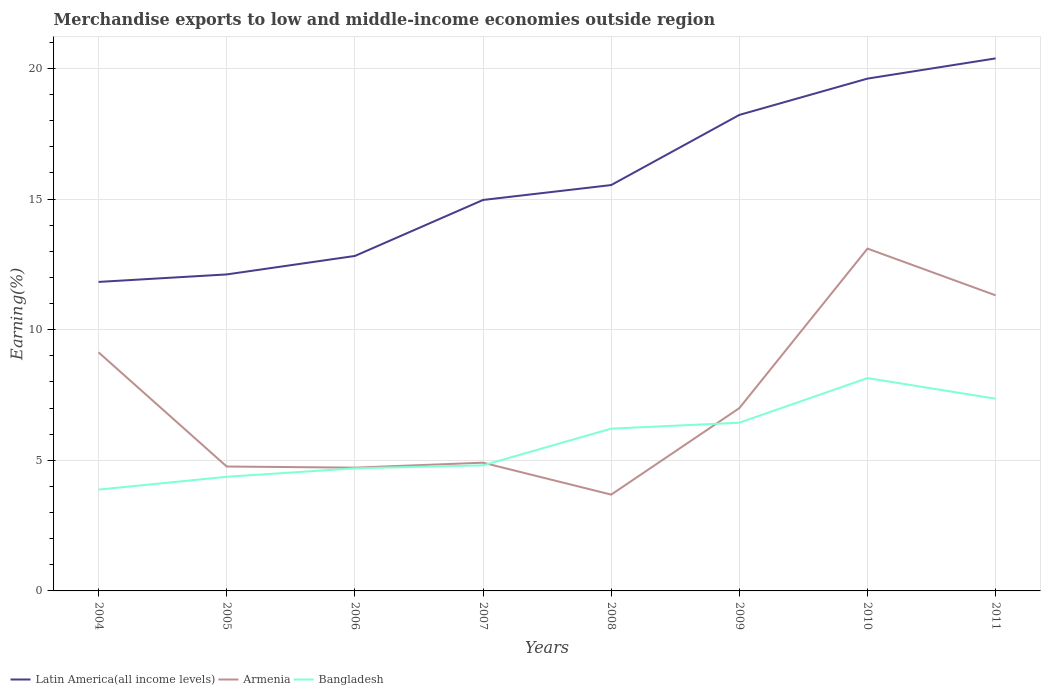Is the number of lines equal to the number of legend labels?
Your answer should be very brief. Yes. Across all years, what is the maximum percentage of amount earned from merchandise exports in Armenia?
Ensure brevity in your answer.  3.69. In which year was the percentage of amount earned from merchandise exports in Latin America(all income levels) maximum?
Ensure brevity in your answer.  2004. What is the total percentage of amount earned from merchandise exports in Latin America(all income levels) in the graph?
Offer a very short reply. -0.57. What is the difference between the highest and the second highest percentage of amount earned from merchandise exports in Bangladesh?
Make the answer very short. 4.27. Is the percentage of amount earned from merchandise exports in Latin America(all income levels) strictly greater than the percentage of amount earned from merchandise exports in Armenia over the years?
Ensure brevity in your answer.  No. How many years are there in the graph?
Offer a terse response. 8. How many legend labels are there?
Give a very brief answer. 3. How are the legend labels stacked?
Provide a short and direct response. Horizontal. What is the title of the graph?
Keep it short and to the point. Merchandise exports to low and middle-income economies outside region. What is the label or title of the Y-axis?
Ensure brevity in your answer.  Earning(%). What is the Earning(%) of Latin America(all income levels) in 2004?
Keep it short and to the point. 11.83. What is the Earning(%) of Armenia in 2004?
Offer a very short reply. 9.13. What is the Earning(%) in Bangladesh in 2004?
Provide a succinct answer. 3.88. What is the Earning(%) in Latin America(all income levels) in 2005?
Make the answer very short. 12.12. What is the Earning(%) in Armenia in 2005?
Make the answer very short. 4.76. What is the Earning(%) in Bangladesh in 2005?
Offer a very short reply. 4.37. What is the Earning(%) in Latin America(all income levels) in 2006?
Your response must be concise. 12.82. What is the Earning(%) in Armenia in 2006?
Keep it short and to the point. 4.72. What is the Earning(%) of Bangladesh in 2006?
Ensure brevity in your answer.  4.69. What is the Earning(%) in Latin America(all income levels) in 2007?
Keep it short and to the point. 14.97. What is the Earning(%) of Armenia in 2007?
Your response must be concise. 4.91. What is the Earning(%) in Bangladesh in 2007?
Offer a very short reply. 4.81. What is the Earning(%) of Latin America(all income levels) in 2008?
Give a very brief answer. 15.54. What is the Earning(%) of Armenia in 2008?
Your response must be concise. 3.69. What is the Earning(%) of Bangladesh in 2008?
Offer a terse response. 6.21. What is the Earning(%) in Latin America(all income levels) in 2009?
Offer a terse response. 18.22. What is the Earning(%) in Armenia in 2009?
Ensure brevity in your answer.  7. What is the Earning(%) of Bangladesh in 2009?
Give a very brief answer. 6.44. What is the Earning(%) of Latin America(all income levels) in 2010?
Offer a terse response. 19.61. What is the Earning(%) of Armenia in 2010?
Provide a short and direct response. 13.1. What is the Earning(%) in Bangladesh in 2010?
Ensure brevity in your answer.  8.15. What is the Earning(%) in Latin America(all income levels) in 2011?
Offer a terse response. 20.39. What is the Earning(%) of Armenia in 2011?
Keep it short and to the point. 11.32. What is the Earning(%) of Bangladesh in 2011?
Your answer should be compact. 7.36. Across all years, what is the maximum Earning(%) in Latin America(all income levels)?
Keep it short and to the point. 20.39. Across all years, what is the maximum Earning(%) of Armenia?
Make the answer very short. 13.1. Across all years, what is the maximum Earning(%) in Bangladesh?
Ensure brevity in your answer.  8.15. Across all years, what is the minimum Earning(%) in Latin America(all income levels)?
Offer a terse response. 11.83. Across all years, what is the minimum Earning(%) in Armenia?
Offer a very short reply. 3.69. Across all years, what is the minimum Earning(%) of Bangladesh?
Provide a succinct answer. 3.88. What is the total Earning(%) of Latin America(all income levels) in the graph?
Your response must be concise. 125.49. What is the total Earning(%) of Armenia in the graph?
Your response must be concise. 58.62. What is the total Earning(%) in Bangladesh in the graph?
Provide a succinct answer. 45.9. What is the difference between the Earning(%) in Latin America(all income levels) in 2004 and that in 2005?
Your answer should be very brief. -0.29. What is the difference between the Earning(%) in Armenia in 2004 and that in 2005?
Your answer should be compact. 4.37. What is the difference between the Earning(%) of Bangladesh in 2004 and that in 2005?
Your response must be concise. -0.49. What is the difference between the Earning(%) of Latin America(all income levels) in 2004 and that in 2006?
Make the answer very short. -0.99. What is the difference between the Earning(%) of Armenia in 2004 and that in 2006?
Provide a succinct answer. 4.41. What is the difference between the Earning(%) of Bangladesh in 2004 and that in 2006?
Your answer should be very brief. -0.81. What is the difference between the Earning(%) of Latin America(all income levels) in 2004 and that in 2007?
Your response must be concise. -3.14. What is the difference between the Earning(%) in Armenia in 2004 and that in 2007?
Your answer should be very brief. 4.22. What is the difference between the Earning(%) of Bangladesh in 2004 and that in 2007?
Keep it short and to the point. -0.93. What is the difference between the Earning(%) of Latin America(all income levels) in 2004 and that in 2008?
Your response must be concise. -3.71. What is the difference between the Earning(%) of Armenia in 2004 and that in 2008?
Your answer should be very brief. 5.45. What is the difference between the Earning(%) of Bangladesh in 2004 and that in 2008?
Your answer should be compact. -2.33. What is the difference between the Earning(%) in Latin America(all income levels) in 2004 and that in 2009?
Your response must be concise. -6.39. What is the difference between the Earning(%) in Armenia in 2004 and that in 2009?
Ensure brevity in your answer.  2.14. What is the difference between the Earning(%) in Bangladesh in 2004 and that in 2009?
Ensure brevity in your answer.  -2.56. What is the difference between the Earning(%) in Latin America(all income levels) in 2004 and that in 2010?
Offer a very short reply. -7.78. What is the difference between the Earning(%) in Armenia in 2004 and that in 2010?
Keep it short and to the point. -3.97. What is the difference between the Earning(%) of Bangladesh in 2004 and that in 2010?
Your answer should be very brief. -4.27. What is the difference between the Earning(%) in Latin America(all income levels) in 2004 and that in 2011?
Offer a very short reply. -8.56. What is the difference between the Earning(%) in Armenia in 2004 and that in 2011?
Offer a very short reply. -2.18. What is the difference between the Earning(%) in Bangladesh in 2004 and that in 2011?
Keep it short and to the point. -3.48. What is the difference between the Earning(%) in Latin America(all income levels) in 2005 and that in 2006?
Your response must be concise. -0.71. What is the difference between the Earning(%) of Armenia in 2005 and that in 2006?
Ensure brevity in your answer.  0.04. What is the difference between the Earning(%) in Bangladesh in 2005 and that in 2006?
Ensure brevity in your answer.  -0.32. What is the difference between the Earning(%) of Latin America(all income levels) in 2005 and that in 2007?
Ensure brevity in your answer.  -2.85. What is the difference between the Earning(%) in Armenia in 2005 and that in 2007?
Provide a succinct answer. -0.15. What is the difference between the Earning(%) in Bangladesh in 2005 and that in 2007?
Ensure brevity in your answer.  -0.44. What is the difference between the Earning(%) of Latin America(all income levels) in 2005 and that in 2008?
Your answer should be compact. -3.42. What is the difference between the Earning(%) of Armenia in 2005 and that in 2008?
Make the answer very short. 1.08. What is the difference between the Earning(%) of Bangladesh in 2005 and that in 2008?
Your answer should be compact. -1.84. What is the difference between the Earning(%) of Latin America(all income levels) in 2005 and that in 2009?
Provide a short and direct response. -6.11. What is the difference between the Earning(%) in Armenia in 2005 and that in 2009?
Ensure brevity in your answer.  -2.24. What is the difference between the Earning(%) in Bangladesh in 2005 and that in 2009?
Your response must be concise. -2.07. What is the difference between the Earning(%) of Latin America(all income levels) in 2005 and that in 2010?
Give a very brief answer. -7.5. What is the difference between the Earning(%) of Armenia in 2005 and that in 2010?
Provide a succinct answer. -8.34. What is the difference between the Earning(%) in Bangladesh in 2005 and that in 2010?
Your answer should be very brief. -3.78. What is the difference between the Earning(%) of Latin America(all income levels) in 2005 and that in 2011?
Provide a short and direct response. -8.27. What is the difference between the Earning(%) of Armenia in 2005 and that in 2011?
Give a very brief answer. -6.55. What is the difference between the Earning(%) in Bangladesh in 2005 and that in 2011?
Provide a succinct answer. -2.99. What is the difference between the Earning(%) of Latin America(all income levels) in 2006 and that in 2007?
Offer a terse response. -2.14. What is the difference between the Earning(%) of Armenia in 2006 and that in 2007?
Offer a very short reply. -0.19. What is the difference between the Earning(%) of Bangladesh in 2006 and that in 2007?
Ensure brevity in your answer.  -0.11. What is the difference between the Earning(%) of Latin America(all income levels) in 2006 and that in 2008?
Provide a succinct answer. -2.71. What is the difference between the Earning(%) in Armenia in 2006 and that in 2008?
Keep it short and to the point. 1.03. What is the difference between the Earning(%) of Bangladesh in 2006 and that in 2008?
Keep it short and to the point. -1.52. What is the difference between the Earning(%) of Latin America(all income levels) in 2006 and that in 2009?
Provide a short and direct response. -5.4. What is the difference between the Earning(%) of Armenia in 2006 and that in 2009?
Offer a terse response. -2.28. What is the difference between the Earning(%) of Bangladesh in 2006 and that in 2009?
Provide a succinct answer. -1.75. What is the difference between the Earning(%) of Latin America(all income levels) in 2006 and that in 2010?
Make the answer very short. -6.79. What is the difference between the Earning(%) of Armenia in 2006 and that in 2010?
Ensure brevity in your answer.  -8.38. What is the difference between the Earning(%) in Bangladesh in 2006 and that in 2010?
Provide a short and direct response. -3.45. What is the difference between the Earning(%) of Latin America(all income levels) in 2006 and that in 2011?
Offer a terse response. -7.56. What is the difference between the Earning(%) in Armenia in 2006 and that in 2011?
Give a very brief answer. -6.6. What is the difference between the Earning(%) of Bangladesh in 2006 and that in 2011?
Your answer should be very brief. -2.66. What is the difference between the Earning(%) of Latin America(all income levels) in 2007 and that in 2008?
Ensure brevity in your answer.  -0.57. What is the difference between the Earning(%) of Armenia in 2007 and that in 2008?
Keep it short and to the point. 1.22. What is the difference between the Earning(%) of Bangladesh in 2007 and that in 2008?
Offer a very short reply. -1.41. What is the difference between the Earning(%) of Latin America(all income levels) in 2007 and that in 2009?
Give a very brief answer. -3.26. What is the difference between the Earning(%) of Armenia in 2007 and that in 2009?
Keep it short and to the point. -2.09. What is the difference between the Earning(%) of Bangladesh in 2007 and that in 2009?
Your response must be concise. -1.63. What is the difference between the Earning(%) of Latin America(all income levels) in 2007 and that in 2010?
Offer a very short reply. -4.65. What is the difference between the Earning(%) of Armenia in 2007 and that in 2010?
Your answer should be very brief. -8.2. What is the difference between the Earning(%) in Bangladesh in 2007 and that in 2010?
Offer a terse response. -3.34. What is the difference between the Earning(%) of Latin America(all income levels) in 2007 and that in 2011?
Make the answer very short. -5.42. What is the difference between the Earning(%) in Armenia in 2007 and that in 2011?
Keep it short and to the point. -6.41. What is the difference between the Earning(%) of Bangladesh in 2007 and that in 2011?
Make the answer very short. -2.55. What is the difference between the Earning(%) of Latin America(all income levels) in 2008 and that in 2009?
Provide a succinct answer. -2.69. What is the difference between the Earning(%) in Armenia in 2008 and that in 2009?
Your answer should be very brief. -3.31. What is the difference between the Earning(%) in Bangladesh in 2008 and that in 2009?
Your answer should be very brief. -0.23. What is the difference between the Earning(%) in Latin America(all income levels) in 2008 and that in 2010?
Give a very brief answer. -4.08. What is the difference between the Earning(%) of Armenia in 2008 and that in 2010?
Make the answer very short. -9.42. What is the difference between the Earning(%) of Bangladesh in 2008 and that in 2010?
Give a very brief answer. -1.94. What is the difference between the Earning(%) in Latin America(all income levels) in 2008 and that in 2011?
Your answer should be compact. -4.85. What is the difference between the Earning(%) of Armenia in 2008 and that in 2011?
Ensure brevity in your answer.  -7.63. What is the difference between the Earning(%) of Bangladesh in 2008 and that in 2011?
Make the answer very short. -1.15. What is the difference between the Earning(%) of Latin America(all income levels) in 2009 and that in 2010?
Provide a succinct answer. -1.39. What is the difference between the Earning(%) in Armenia in 2009 and that in 2010?
Offer a terse response. -6.11. What is the difference between the Earning(%) in Bangladesh in 2009 and that in 2010?
Provide a succinct answer. -1.71. What is the difference between the Earning(%) of Latin America(all income levels) in 2009 and that in 2011?
Provide a short and direct response. -2.16. What is the difference between the Earning(%) in Armenia in 2009 and that in 2011?
Your answer should be compact. -4.32. What is the difference between the Earning(%) of Bangladesh in 2009 and that in 2011?
Offer a very short reply. -0.92. What is the difference between the Earning(%) in Latin America(all income levels) in 2010 and that in 2011?
Ensure brevity in your answer.  -0.77. What is the difference between the Earning(%) in Armenia in 2010 and that in 2011?
Offer a terse response. 1.79. What is the difference between the Earning(%) of Bangladesh in 2010 and that in 2011?
Ensure brevity in your answer.  0.79. What is the difference between the Earning(%) in Latin America(all income levels) in 2004 and the Earning(%) in Armenia in 2005?
Provide a succinct answer. 7.07. What is the difference between the Earning(%) of Latin America(all income levels) in 2004 and the Earning(%) of Bangladesh in 2005?
Provide a short and direct response. 7.46. What is the difference between the Earning(%) of Armenia in 2004 and the Earning(%) of Bangladesh in 2005?
Your answer should be very brief. 4.76. What is the difference between the Earning(%) of Latin America(all income levels) in 2004 and the Earning(%) of Armenia in 2006?
Ensure brevity in your answer.  7.11. What is the difference between the Earning(%) in Latin America(all income levels) in 2004 and the Earning(%) in Bangladesh in 2006?
Give a very brief answer. 7.13. What is the difference between the Earning(%) of Armenia in 2004 and the Earning(%) of Bangladesh in 2006?
Offer a terse response. 4.44. What is the difference between the Earning(%) of Latin America(all income levels) in 2004 and the Earning(%) of Armenia in 2007?
Your answer should be very brief. 6.92. What is the difference between the Earning(%) in Latin America(all income levels) in 2004 and the Earning(%) in Bangladesh in 2007?
Make the answer very short. 7.02. What is the difference between the Earning(%) of Armenia in 2004 and the Earning(%) of Bangladesh in 2007?
Offer a very short reply. 4.33. What is the difference between the Earning(%) of Latin America(all income levels) in 2004 and the Earning(%) of Armenia in 2008?
Offer a very short reply. 8.14. What is the difference between the Earning(%) in Latin America(all income levels) in 2004 and the Earning(%) in Bangladesh in 2008?
Keep it short and to the point. 5.62. What is the difference between the Earning(%) in Armenia in 2004 and the Earning(%) in Bangladesh in 2008?
Give a very brief answer. 2.92. What is the difference between the Earning(%) of Latin America(all income levels) in 2004 and the Earning(%) of Armenia in 2009?
Provide a succinct answer. 4.83. What is the difference between the Earning(%) in Latin America(all income levels) in 2004 and the Earning(%) in Bangladesh in 2009?
Offer a terse response. 5.39. What is the difference between the Earning(%) in Armenia in 2004 and the Earning(%) in Bangladesh in 2009?
Ensure brevity in your answer.  2.69. What is the difference between the Earning(%) in Latin America(all income levels) in 2004 and the Earning(%) in Armenia in 2010?
Your answer should be very brief. -1.28. What is the difference between the Earning(%) in Latin America(all income levels) in 2004 and the Earning(%) in Bangladesh in 2010?
Offer a terse response. 3.68. What is the difference between the Earning(%) of Armenia in 2004 and the Earning(%) of Bangladesh in 2010?
Provide a succinct answer. 0.98. What is the difference between the Earning(%) in Latin America(all income levels) in 2004 and the Earning(%) in Armenia in 2011?
Make the answer very short. 0.51. What is the difference between the Earning(%) of Latin America(all income levels) in 2004 and the Earning(%) of Bangladesh in 2011?
Provide a short and direct response. 4.47. What is the difference between the Earning(%) in Armenia in 2004 and the Earning(%) in Bangladesh in 2011?
Your answer should be compact. 1.78. What is the difference between the Earning(%) in Latin America(all income levels) in 2005 and the Earning(%) in Armenia in 2006?
Make the answer very short. 7.4. What is the difference between the Earning(%) of Latin America(all income levels) in 2005 and the Earning(%) of Bangladesh in 2006?
Provide a short and direct response. 7.42. What is the difference between the Earning(%) of Armenia in 2005 and the Earning(%) of Bangladesh in 2006?
Your answer should be very brief. 0.07. What is the difference between the Earning(%) of Latin America(all income levels) in 2005 and the Earning(%) of Armenia in 2007?
Offer a terse response. 7.21. What is the difference between the Earning(%) in Latin America(all income levels) in 2005 and the Earning(%) in Bangladesh in 2007?
Provide a succinct answer. 7.31. What is the difference between the Earning(%) of Armenia in 2005 and the Earning(%) of Bangladesh in 2007?
Your answer should be very brief. -0.05. What is the difference between the Earning(%) of Latin America(all income levels) in 2005 and the Earning(%) of Armenia in 2008?
Your response must be concise. 8.43. What is the difference between the Earning(%) of Latin America(all income levels) in 2005 and the Earning(%) of Bangladesh in 2008?
Keep it short and to the point. 5.9. What is the difference between the Earning(%) in Armenia in 2005 and the Earning(%) in Bangladesh in 2008?
Your answer should be very brief. -1.45. What is the difference between the Earning(%) in Latin America(all income levels) in 2005 and the Earning(%) in Armenia in 2009?
Your response must be concise. 5.12. What is the difference between the Earning(%) in Latin America(all income levels) in 2005 and the Earning(%) in Bangladesh in 2009?
Your response must be concise. 5.68. What is the difference between the Earning(%) in Armenia in 2005 and the Earning(%) in Bangladesh in 2009?
Give a very brief answer. -1.68. What is the difference between the Earning(%) of Latin America(all income levels) in 2005 and the Earning(%) of Armenia in 2010?
Keep it short and to the point. -0.99. What is the difference between the Earning(%) in Latin America(all income levels) in 2005 and the Earning(%) in Bangladesh in 2010?
Provide a succinct answer. 3.97. What is the difference between the Earning(%) of Armenia in 2005 and the Earning(%) of Bangladesh in 2010?
Your answer should be very brief. -3.39. What is the difference between the Earning(%) of Latin America(all income levels) in 2005 and the Earning(%) of Armenia in 2011?
Make the answer very short. 0.8. What is the difference between the Earning(%) of Latin America(all income levels) in 2005 and the Earning(%) of Bangladesh in 2011?
Provide a short and direct response. 4.76. What is the difference between the Earning(%) in Armenia in 2005 and the Earning(%) in Bangladesh in 2011?
Make the answer very short. -2.6. What is the difference between the Earning(%) in Latin America(all income levels) in 2006 and the Earning(%) in Armenia in 2007?
Provide a succinct answer. 7.91. What is the difference between the Earning(%) in Latin America(all income levels) in 2006 and the Earning(%) in Bangladesh in 2007?
Give a very brief answer. 8.02. What is the difference between the Earning(%) of Armenia in 2006 and the Earning(%) of Bangladesh in 2007?
Offer a very short reply. -0.09. What is the difference between the Earning(%) in Latin America(all income levels) in 2006 and the Earning(%) in Armenia in 2008?
Provide a short and direct response. 9.14. What is the difference between the Earning(%) in Latin America(all income levels) in 2006 and the Earning(%) in Bangladesh in 2008?
Provide a short and direct response. 6.61. What is the difference between the Earning(%) of Armenia in 2006 and the Earning(%) of Bangladesh in 2008?
Offer a terse response. -1.49. What is the difference between the Earning(%) in Latin America(all income levels) in 2006 and the Earning(%) in Armenia in 2009?
Provide a short and direct response. 5.83. What is the difference between the Earning(%) of Latin America(all income levels) in 2006 and the Earning(%) of Bangladesh in 2009?
Give a very brief answer. 6.38. What is the difference between the Earning(%) of Armenia in 2006 and the Earning(%) of Bangladesh in 2009?
Offer a terse response. -1.72. What is the difference between the Earning(%) of Latin America(all income levels) in 2006 and the Earning(%) of Armenia in 2010?
Make the answer very short. -0.28. What is the difference between the Earning(%) of Latin America(all income levels) in 2006 and the Earning(%) of Bangladesh in 2010?
Your answer should be compact. 4.67. What is the difference between the Earning(%) in Armenia in 2006 and the Earning(%) in Bangladesh in 2010?
Provide a succinct answer. -3.43. What is the difference between the Earning(%) of Latin America(all income levels) in 2006 and the Earning(%) of Armenia in 2011?
Keep it short and to the point. 1.51. What is the difference between the Earning(%) of Latin America(all income levels) in 2006 and the Earning(%) of Bangladesh in 2011?
Provide a short and direct response. 5.47. What is the difference between the Earning(%) of Armenia in 2006 and the Earning(%) of Bangladesh in 2011?
Your answer should be compact. -2.64. What is the difference between the Earning(%) of Latin America(all income levels) in 2007 and the Earning(%) of Armenia in 2008?
Ensure brevity in your answer.  11.28. What is the difference between the Earning(%) of Latin America(all income levels) in 2007 and the Earning(%) of Bangladesh in 2008?
Provide a succinct answer. 8.75. What is the difference between the Earning(%) in Armenia in 2007 and the Earning(%) in Bangladesh in 2008?
Keep it short and to the point. -1.3. What is the difference between the Earning(%) of Latin America(all income levels) in 2007 and the Earning(%) of Armenia in 2009?
Your answer should be compact. 7.97. What is the difference between the Earning(%) of Latin America(all income levels) in 2007 and the Earning(%) of Bangladesh in 2009?
Your response must be concise. 8.53. What is the difference between the Earning(%) of Armenia in 2007 and the Earning(%) of Bangladesh in 2009?
Provide a succinct answer. -1.53. What is the difference between the Earning(%) of Latin America(all income levels) in 2007 and the Earning(%) of Armenia in 2010?
Offer a very short reply. 1.86. What is the difference between the Earning(%) in Latin America(all income levels) in 2007 and the Earning(%) in Bangladesh in 2010?
Offer a very short reply. 6.82. What is the difference between the Earning(%) of Armenia in 2007 and the Earning(%) of Bangladesh in 2010?
Offer a terse response. -3.24. What is the difference between the Earning(%) of Latin America(all income levels) in 2007 and the Earning(%) of Armenia in 2011?
Give a very brief answer. 3.65. What is the difference between the Earning(%) of Latin America(all income levels) in 2007 and the Earning(%) of Bangladesh in 2011?
Your response must be concise. 7.61. What is the difference between the Earning(%) in Armenia in 2007 and the Earning(%) in Bangladesh in 2011?
Give a very brief answer. -2.45. What is the difference between the Earning(%) of Latin America(all income levels) in 2008 and the Earning(%) of Armenia in 2009?
Ensure brevity in your answer.  8.54. What is the difference between the Earning(%) of Latin America(all income levels) in 2008 and the Earning(%) of Bangladesh in 2009?
Your answer should be very brief. 9.1. What is the difference between the Earning(%) of Armenia in 2008 and the Earning(%) of Bangladesh in 2009?
Provide a succinct answer. -2.75. What is the difference between the Earning(%) of Latin America(all income levels) in 2008 and the Earning(%) of Armenia in 2010?
Your answer should be compact. 2.43. What is the difference between the Earning(%) of Latin America(all income levels) in 2008 and the Earning(%) of Bangladesh in 2010?
Offer a terse response. 7.39. What is the difference between the Earning(%) of Armenia in 2008 and the Earning(%) of Bangladesh in 2010?
Make the answer very short. -4.46. What is the difference between the Earning(%) in Latin America(all income levels) in 2008 and the Earning(%) in Armenia in 2011?
Provide a short and direct response. 4.22. What is the difference between the Earning(%) in Latin America(all income levels) in 2008 and the Earning(%) in Bangladesh in 2011?
Your answer should be compact. 8.18. What is the difference between the Earning(%) in Armenia in 2008 and the Earning(%) in Bangladesh in 2011?
Keep it short and to the point. -3.67. What is the difference between the Earning(%) of Latin America(all income levels) in 2009 and the Earning(%) of Armenia in 2010?
Offer a very short reply. 5.12. What is the difference between the Earning(%) of Latin America(all income levels) in 2009 and the Earning(%) of Bangladesh in 2010?
Your response must be concise. 10.07. What is the difference between the Earning(%) of Armenia in 2009 and the Earning(%) of Bangladesh in 2010?
Offer a terse response. -1.15. What is the difference between the Earning(%) in Latin America(all income levels) in 2009 and the Earning(%) in Armenia in 2011?
Give a very brief answer. 6.91. What is the difference between the Earning(%) in Latin America(all income levels) in 2009 and the Earning(%) in Bangladesh in 2011?
Offer a terse response. 10.86. What is the difference between the Earning(%) in Armenia in 2009 and the Earning(%) in Bangladesh in 2011?
Keep it short and to the point. -0.36. What is the difference between the Earning(%) in Latin America(all income levels) in 2010 and the Earning(%) in Armenia in 2011?
Your answer should be very brief. 8.3. What is the difference between the Earning(%) in Latin America(all income levels) in 2010 and the Earning(%) in Bangladesh in 2011?
Offer a terse response. 12.25. What is the difference between the Earning(%) of Armenia in 2010 and the Earning(%) of Bangladesh in 2011?
Give a very brief answer. 5.75. What is the average Earning(%) in Latin America(all income levels) per year?
Make the answer very short. 15.69. What is the average Earning(%) in Armenia per year?
Give a very brief answer. 7.33. What is the average Earning(%) of Bangladesh per year?
Give a very brief answer. 5.74. In the year 2004, what is the difference between the Earning(%) of Latin America(all income levels) and Earning(%) of Armenia?
Make the answer very short. 2.7. In the year 2004, what is the difference between the Earning(%) in Latin America(all income levels) and Earning(%) in Bangladesh?
Your answer should be compact. 7.95. In the year 2004, what is the difference between the Earning(%) of Armenia and Earning(%) of Bangladesh?
Provide a short and direct response. 5.25. In the year 2005, what is the difference between the Earning(%) of Latin America(all income levels) and Earning(%) of Armenia?
Provide a short and direct response. 7.35. In the year 2005, what is the difference between the Earning(%) of Latin America(all income levels) and Earning(%) of Bangladesh?
Your answer should be very brief. 7.75. In the year 2005, what is the difference between the Earning(%) of Armenia and Earning(%) of Bangladesh?
Offer a very short reply. 0.39. In the year 2006, what is the difference between the Earning(%) of Latin America(all income levels) and Earning(%) of Armenia?
Make the answer very short. 8.1. In the year 2006, what is the difference between the Earning(%) of Latin America(all income levels) and Earning(%) of Bangladesh?
Make the answer very short. 8.13. In the year 2006, what is the difference between the Earning(%) of Armenia and Earning(%) of Bangladesh?
Your response must be concise. 0.03. In the year 2007, what is the difference between the Earning(%) of Latin America(all income levels) and Earning(%) of Armenia?
Provide a succinct answer. 10.06. In the year 2007, what is the difference between the Earning(%) in Latin America(all income levels) and Earning(%) in Bangladesh?
Your answer should be very brief. 10.16. In the year 2007, what is the difference between the Earning(%) of Armenia and Earning(%) of Bangladesh?
Make the answer very short. 0.1. In the year 2008, what is the difference between the Earning(%) in Latin America(all income levels) and Earning(%) in Armenia?
Offer a terse response. 11.85. In the year 2008, what is the difference between the Earning(%) of Latin America(all income levels) and Earning(%) of Bangladesh?
Provide a short and direct response. 9.32. In the year 2008, what is the difference between the Earning(%) in Armenia and Earning(%) in Bangladesh?
Offer a very short reply. -2.53. In the year 2009, what is the difference between the Earning(%) of Latin America(all income levels) and Earning(%) of Armenia?
Make the answer very short. 11.22. In the year 2009, what is the difference between the Earning(%) in Latin America(all income levels) and Earning(%) in Bangladesh?
Your answer should be very brief. 11.78. In the year 2009, what is the difference between the Earning(%) in Armenia and Earning(%) in Bangladesh?
Give a very brief answer. 0.56. In the year 2010, what is the difference between the Earning(%) of Latin America(all income levels) and Earning(%) of Armenia?
Provide a succinct answer. 6.51. In the year 2010, what is the difference between the Earning(%) of Latin America(all income levels) and Earning(%) of Bangladesh?
Give a very brief answer. 11.46. In the year 2010, what is the difference between the Earning(%) in Armenia and Earning(%) in Bangladesh?
Make the answer very short. 4.96. In the year 2011, what is the difference between the Earning(%) in Latin America(all income levels) and Earning(%) in Armenia?
Give a very brief answer. 9.07. In the year 2011, what is the difference between the Earning(%) of Latin America(all income levels) and Earning(%) of Bangladesh?
Your answer should be very brief. 13.03. In the year 2011, what is the difference between the Earning(%) of Armenia and Earning(%) of Bangladesh?
Provide a succinct answer. 3.96. What is the ratio of the Earning(%) of Latin America(all income levels) in 2004 to that in 2005?
Your answer should be compact. 0.98. What is the ratio of the Earning(%) of Armenia in 2004 to that in 2005?
Make the answer very short. 1.92. What is the ratio of the Earning(%) in Bangladesh in 2004 to that in 2005?
Give a very brief answer. 0.89. What is the ratio of the Earning(%) of Latin America(all income levels) in 2004 to that in 2006?
Provide a short and direct response. 0.92. What is the ratio of the Earning(%) in Armenia in 2004 to that in 2006?
Ensure brevity in your answer.  1.94. What is the ratio of the Earning(%) of Bangladesh in 2004 to that in 2006?
Provide a short and direct response. 0.83. What is the ratio of the Earning(%) in Latin America(all income levels) in 2004 to that in 2007?
Offer a terse response. 0.79. What is the ratio of the Earning(%) in Armenia in 2004 to that in 2007?
Ensure brevity in your answer.  1.86. What is the ratio of the Earning(%) in Bangladesh in 2004 to that in 2007?
Provide a short and direct response. 0.81. What is the ratio of the Earning(%) in Latin America(all income levels) in 2004 to that in 2008?
Provide a short and direct response. 0.76. What is the ratio of the Earning(%) in Armenia in 2004 to that in 2008?
Make the answer very short. 2.48. What is the ratio of the Earning(%) of Bangladesh in 2004 to that in 2008?
Give a very brief answer. 0.62. What is the ratio of the Earning(%) in Latin America(all income levels) in 2004 to that in 2009?
Keep it short and to the point. 0.65. What is the ratio of the Earning(%) in Armenia in 2004 to that in 2009?
Provide a succinct answer. 1.31. What is the ratio of the Earning(%) in Bangladesh in 2004 to that in 2009?
Offer a terse response. 0.6. What is the ratio of the Earning(%) in Latin America(all income levels) in 2004 to that in 2010?
Make the answer very short. 0.6. What is the ratio of the Earning(%) in Armenia in 2004 to that in 2010?
Make the answer very short. 0.7. What is the ratio of the Earning(%) of Bangladesh in 2004 to that in 2010?
Provide a succinct answer. 0.48. What is the ratio of the Earning(%) in Latin America(all income levels) in 2004 to that in 2011?
Offer a very short reply. 0.58. What is the ratio of the Earning(%) in Armenia in 2004 to that in 2011?
Offer a very short reply. 0.81. What is the ratio of the Earning(%) in Bangladesh in 2004 to that in 2011?
Give a very brief answer. 0.53. What is the ratio of the Earning(%) in Latin America(all income levels) in 2005 to that in 2006?
Your answer should be compact. 0.94. What is the ratio of the Earning(%) of Armenia in 2005 to that in 2006?
Your answer should be compact. 1.01. What is the ratio of the Earning(%) in Latin America(all income levels) in 2005 to that in 2007?
Your response must be concise. 0.81. What is the ratio of the Earning(%) of Armenia in 2005 to that in 2007?
Make the answer very short. 0.97. What is the ratio of the Earning(%) of Bangladesh in 2005 to that in 2007?
Keep it short and to the point. 0.91. What is the ratio of the Earning(%) in Latin America(all income levels) in 2005 to that in 2008?
Ensure brevity in your answer.  0.78. What is the ratio of the Earning(%) in Armenia in 2005 to that in 2008?
Keep it short and to the point. 1.29. What is the ratio of the Earning(%) in Bangladesh in 2005 to that in 2008?
Ensure brevity in your answer.  0.7. What is the ratio of the Earning(%) of Latin America(all income levels) in 2005 to that in 2009?
Offer a terse response. 0.66. What is the ratio of the Earning(%) in Armenia in 2005 to that in 2009?
Provide a short and direct response. 0.68. What is the ratio of the Earning(%) of Bangladesh in 2005 to that in 2009?
Provide a succinct answer. 0.68. What is the ratio of the Earning(%) of Latin America(all income levels) in 2005 to that in 2010?
Your answer should be compact. 0.62. What is the ratio of the Earning(%) in Armenia in 2005 to that in 2010?
Provide a succinct answer. 0.36. What is the ratio of the Earning(%) in Bangladesh in 2005 to that in 2010?
Provide a short and direct response. 0.54. What is the ratio of the Earning(%) of Latin America(all income levels) in 2005 to that in 2011?
Ensure brevity in your answer.  0.59. What is the ratio of the Earning(%) in Armenia in 2005 to that in 2011?
Your answer should be compact. 0.42. What is the ratio of the Earning(%) in Bangladesh in 2005 to that in 2011?
Keep it short and to the point. 0.59. What is the ratio of the Earning(%) of Latin America(all income levels) in 2006 to that in 2007?
Offer a terse response. 0.86. What is the ratio of the Earning(%) of Armenia in 2006 to that in 2007?
Your answer should be very brief. 0.96. What is the ratio of the Earning(%) of Bangladesh in 2006 to that in 2007?
Your answer should be very brief. 0.98. What is the ratio of the Earning(%) in Latin America(all income levels) in 2006 to that in 2008?
Keep it short and to the point. 0.83. What is the ratio of the Earning(%) in Armenia in 2006 to that in 2008?
Ensure brevity in your answer.  1.28. What is the ratio of the Earning(%) of Bangladesh in 2006 to that in 2008?
Your answer should be compact. 0.76. What is the ratio of the Earning(%) of Latin America(all income levels) in 2006 to that in 2009?
Offer a terse response. 0.7. What is the ratio of the Earning(%) of Armenia in 2006 to that in 2009?
Provide a succinct answer. 0.67. What is the ratio of the Earning(%) in Bangladesh in 2006 to that in 2009?
Provide a short and direct response. 0.73. What is the ratio of the Earning(%) in Latin America(all income levels) in 2006 to that in 2010?
Offer a very short reply. 0.65. What is the ratio of the Earning(%) in Armenia in 2006 to that in 2010?
Your answer should be compact. 0.36. What is the ratio of the Earning(%) in Bangladesh in 2006 to that in 2010?
Keep it short and to the point. 0.58. What is the ratio of the Earning(%) of Latin America(all income levels) in 2006 to that in 2011?
Offer a terse response. 0.63. What is the ratio of the Earning(%) in Armenia in 2006 to that in 2011?
Keep it short and to the point. 0.42. What is the ratio of the Earning(%) of Bangladesh in 2006 to that in 2011?
Make the answer very short. 0.64. What is the ratio of the Earning(%) of Latin America(all income levels) in 2007 to that in 2008?
Your answer should be very brief. 0.96. What is the ratio of the Earning(%) in Armenia in 2007 to that in 2008?
Offer a very short reply. 1.33. What is the ratio of the Earning(%) in Bangladesh in 2007 to that in 2008?
Provide a short and direct response. 0.77. What is the ratio of the Earning(%) of Latin America(all income levels) in 2007 to that in 2009?
Offer a very short reply. 0.82. What is the ratio of the Earning(%) of Armenia in 2007 to that in 2009?
Give a very brief answer. 0.7. What is the ratio of the Earning(%) of Bangladesh in 2007 to that in 2009?
Provide a succinct answer. 0.75. What is the ratio of the Earning(%) of Latin America(all income levels) in 2007 to that in 2010?
Make the answer very short. 0.76. What is the ratio of the Earning(%) of Armenia in 2007 to that in 2010?
Your answer should be very brief. 0.37. What is the ratio of the Earning(%) in Bangladesh in 2007 to that in 2010?
Make the answer very short. 0.59. What is the ratio of the Earning(%) of Latin America(all income levels) in 2007 to that in 2011?
Your answer should be very brief. 0.73. What is the ratio of the Earning(%) of Armenia in 2007 to that in 2011?
Provide a succinct answer. 0.43. What is the ratio of the Earning(%) of Bangladesh in 2007 to that in 2011?
Provide a short and direct response. 0.65. What is the ratio of the Earning(%) in Latin America(all income levels) in 2008 to that in 2009?
Your answer should be compact. 0.85. What is the ratio of the Earning(%) in Armenia in 2008 to that in 2009?
Give a very brief answer. 0.53. What is the ratio of the Earning(%) in Bangladesh in 2008 to that in 2009?
Your response must be concise. 0.96. What is the ratio of the Earning(%) of Latin America(all income levels) in 2008 to that in 2010?
Provide a succinct answer. 0.79. What is the ratio of the Earning(%) in Armenia in 2008 to that in 2010?
Ensure brevity in your answer.  0.28. What is the ratio of the Earning(%) in Bangladesh in 2008 to that in 2010?
Your response must be concise. 0.76. What is the ratio of the Earning(%) of Latin America(all income levels) in 2008 to that in 2011?
Give a very brief answer. 0.76. What is the ratio of the Earning(%) of Armenia in 2008 to that in 2011?
Ensure brevity in your answer.  0.33. What is the ratio of the Earning(%) in Bangladesh in 2008 to that in 2011?
Your answer should be very brief. 0.84. What is the ratio of the Earning(%) in Latin America(all income levels) in 2009 to that in 2010?
Your answer should be very brief. 0.93. What is the ratio of the Earning(%) in Armenia in 2009 to that in 2010?
Provide a succinct answer. 0.53. What is the ratio of the Earning(%) of Bangladesh in 2009 to that in 2010?
Your answer should be very brief. 0.79. What is the ratio of the Earning(%) in Latin America(all income levels) in 2009 to that in 2011?
Ensure brevity in your answer.  0.89. What is the ratio of the Earning(%) of Armenia in 2009 to that in 2011?
Provide a succinct answer. 0.62. What is the ratio of the Earning(%) in Bangladesh in 2009 to that in 2011?
Offer a very short reply. 0.88. What is the ratio of the Earning(%) in Latin America(all income levels) in 2010 to that in 2011?
Your answer should be very brief. 0.96. What is the ratio of the Earning(%) in Armenia in 2010 to that in 2011?
Provide a short and direct response. 1.16. What is the ratio of the Earning(%) in Bangladesh in 2010 to that in 2011?
Provide a succinct answer. 1.11. What is the difference between the highest and the second highest Earning(%) in Latin America(all income levels)?
Offer a terse response. 0.77. What is the difference between the highest and the second highest Earning(%) of Armenia?
Provide a succinct answer. 1.79. What is the difference between the highest and the second highest Earning(%) in Bangladesh?
Keep it short and to the point. 0.79. What is the difference between the highest and the lowest Earning(%) in Latin America(all income levels)?
Ensure brevity in your answer.  8.56. What is the difference between the highest and the lowest Earning(%) in Armenia?
Your answer should be very brief. 9.42. What is the difference between the highest and the lowest Earning(%) of Bangladesh?
Your answer should be compact. 4.27. 